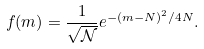<formula> <loc_0><loc_0><loc_500><loc_500>f ( m ) = \frac { 1 } { \sqrt { \mathcal { N } } } e ^ { - ( m - N ) ^ { 2 } / 4 N } .</formula> 